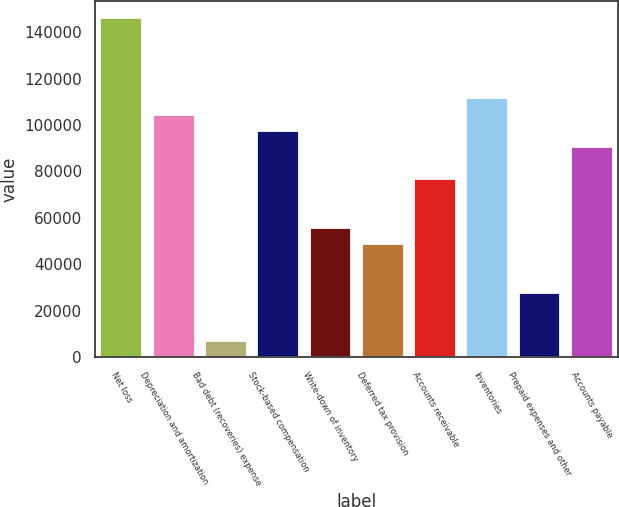<chart> <loc_0><loc_0><loc_500><loc_500><bar_chart><fcel>Net loss<fcel>Depreciation and amortization<fcel>Bad debt (recoveries) expense<fcel>Stock-based compensation<fcel>Write-down of inventory<fcel>Deferred tax provision<fcel>Accounts receivable<fcel>Inventories<fcel>Prepaid expenses and other<fcel>Accounts payable<nl><fcel>146221<fcel>104453<fcel>6993.4<fcel>97491.6<fcel>55723.2<fcel>48761.8<fcel>76607.4<fcel>111414<fcel>27877.6<fcel>90530.2<nl></chart> 